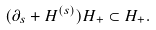<formula> <loc_0><loc_0><loc_500><loc_500>( \partial _ { s } + H ^ { ( s ) } ) H _ { + } \subset H _ { + } .</formula> 